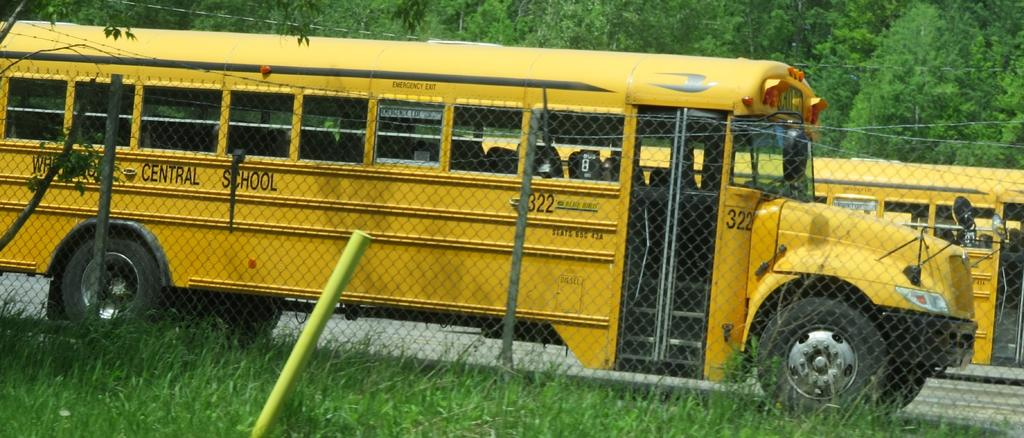What is located on the grass in the image? There is a pole on the grass. What type of barrier can be seen in the image? There is a fence in the image. What can be seen in the background of the image? There are two vehicles on the road and trees in the background. Are there any additional structures visible in the background? Yes, there are wires in the background. What type of health advice is being given in the image? There is no indication of health advice being given in the image. What color is the sweater worn by the person in the image? There is no person or sweater present in the image. How many boats can be seen in the image? There are no boats present in the image. 